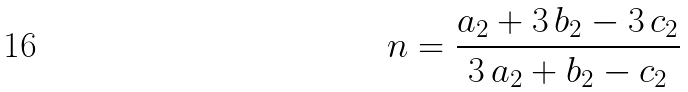<formula> <loc_0><loc_0><loc_500><loc_500>n = \frac { a _ { 2 } + 3 \, b _ { 2 } - 3 \, c _ { 2 } } { 3 \, a _ { 2 } + b _ { 2 } - c _ { 2 } }</formula> 